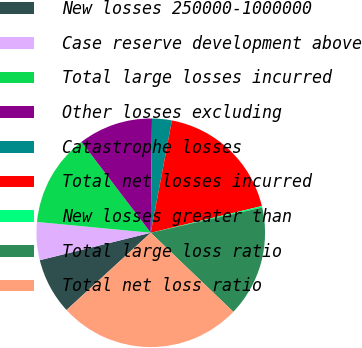Convert chart to OTSL. <chart><loc_0><loc_0><loc_500><loc_500><pie_chart><fcel>New losses 250000-1000000<fcel>Case reserve development above<fcel>Total large losses incurred<fcel>Other losses excluding<fcel>Catastrophe losses<fcel>Total net losses incurred<fcel>New losses greater than<fcel>Total large loss ratio<fcel>Total net loss ratio<nl><fcel>7.95%<fcel>5.37%<fcel>13.12%<fcel>10.54%<fcel>2.79%<fcel>18.28%<fcel>0.21%<fcel>15.7%<fcel>26.04%<nl></chart> 